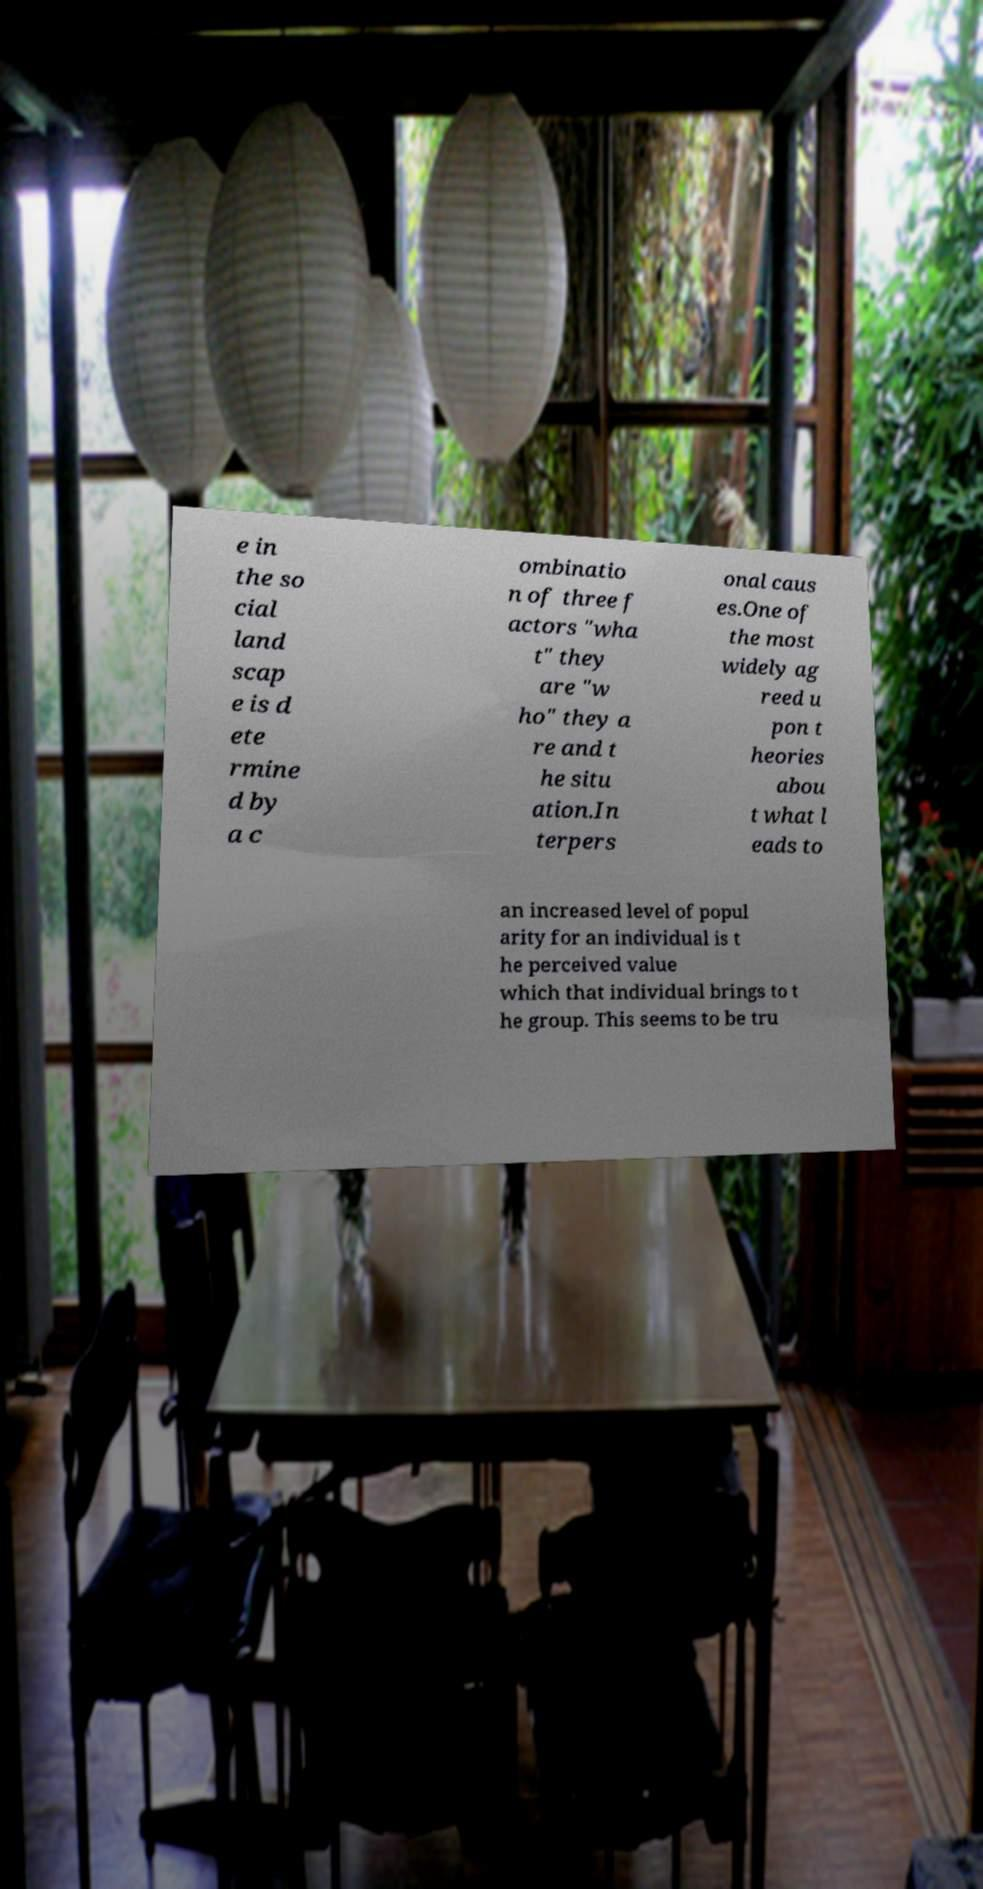Could you extract and type out the text from this image? e in the so cial land scap e is d ete rmine d by a c ombinatio n of three f actors "wha t" they are "w ho" they a re and t he situ ation.In terpers onal caus es.One of the most widely ag reed u pon t heories abou t what l eads to an increased level of popul arity for an individual is t he perceived value which that individual brings to t he group. This seems to be tru 